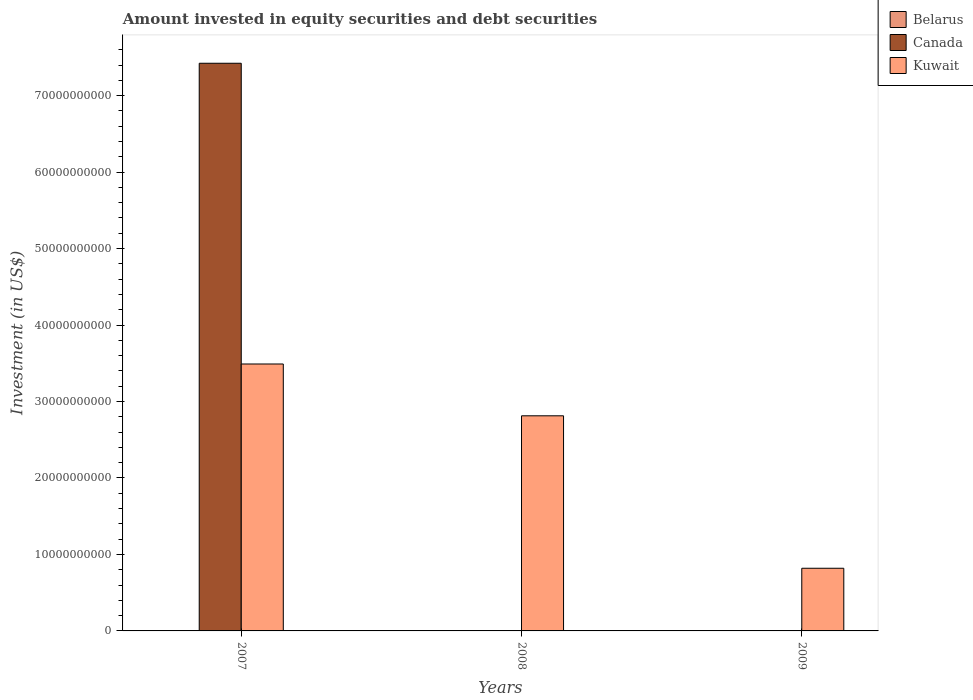How many different coloured bars are there?
Your answer should be compact. 3. Are the number of bars per tick equal to the number of legend labels?
Your answer should be very brief. No. Are the number of bars on each tick of the X-axis equal?
Make the answer very short. No. What is the label of the 3rd group of bars from the left?
Make the answer very short. 2009. In how many cases, is the number of bars for a given year not equal to the number of legend labels?
Make the answer very short. 2. What is the amount invested in equity securities and debt securities in Belarus in 2007?
Give a very brief answer. 3.88e+07. Across all years, what is the maximum amount invested in equity securities and debt securities in Kuwait?
Offer a very short reply. 3.49e+1. Across all years, what is the minimum amount invested in equity securities and debt securities in Canada?
Make the answer very short. 0. In which year was the amount invested in equity securities and debt securities in Belarus maximum?
Provide a succinct answer. 2007. What is the total amount invested in equity securities and debt securities in Kuwait in the graph?
Your answer should be compact. 7.12e+1. What is the difference between the amount invested in equity securities and debt securities in Kuwait in 2007 and that in 2009?
Your response must be concise. 2.67e+1. What is the difference between the amount invested in equity securities and debt securities in Kuwait in 2007 and the amount invested in equity securities and debt securities in Belarus in 2009?
Your answer should be very brief. 3.49e+1. What is the average amount invested in equity securities and debt securities in Kuwait per year?
Your answer should be compact. 2.37e+1. In the year 2007, what is the difference between the amount invested in equity securities and debt securities in Canada and amount invested in equity securities and debt securities in Belarus?
Your response must be concise. 7.42e+1. In how many years, is the amount invested in equity securities and debt securities in Belarus greater than 28000000000 US$?
Make the answer very short. 0. What is the ratio of the amount invested in equity securities and debt securities in Kuwait in 2007 to that in 2009?
Your answer should be very brief. 4.26. What is the difference between the highest and the second highest amount invested in equity securities and debt securities in Kuwait?
Provide a succinct answer. 6.77e+09. What is the difference between the highest and the lowest amount invested in equity securities and debt securities in Belarus?
Offer a very short reply. 3.88e+07. In how many years, is the amount invested in equity securities and debt securities in Kuwait greater than the average amount invested in equity securities and debt securities in Kuwait taken over all years?
Give a very brief answer. 2. Is it the case that in every year, the sum of the amount invested in equity securities and debt securities in Canada and amount invested in equity securities and debt securities in Kuwait is greater than the amount invested in equity securities and debt securities in Belarus?
Provide a short and direct response. Yes. How many bars are there?
Offer a very short reply. 5. Are all the bars in the graph horizontal?
Give a very brief answer. No. How many years are there in the graph?
Make the answer very short. 3. What is the difference between two consecutive major ticks on the Y-axis?
Provide a short and direct response. 1.00e+1. Are the values on the major ticks of Y-axis written in scientific E-notation?
Ensure brevity in your answer.  No. Does the graph contain grids?
Your response must be concise. No. How many legend labels are there?
Keep it short and to the point. 3. How are the legend labels stacked?
Provide a short and direct response. Vertical. What is the title of the graph?
Provide a short and direct response. Amount invested in equity securities and debt securities. What is the label or title of the Y-axis?
Provide a succinct answer. Investment (in US$). What is the Investment (in US$) in Belarus in 2007?
Your answer should be compact. 3.88e+07. What is the Investment (in US$) in Canada in 2007?
Give a very brief answer. 7.42e+1. What is the Investment (in US$) of Kuwait in 2007?
Your response must be concise. 3.49e+1. What is the Investment (in US$) in Belarus in 2008?
Give a very brief answer. 0. What is the Investment (in US$) of Kuwait in 2008?
Offer a very short reply. 2.81e+1. What is the Investment (in US$) of Belarus in 2009?
Your response must be concise. 0. What is the Investment (in US$) in Kuwait in 2009?
Your response must be concise. 8.19e+09. Across all years, what is the maximum Investment (in US$) in Belarus?
Your answer should be compact. 3.88e+07. Across all years, what is the maximum Investment (in US$) in Canada?
Ensure brevity in your answer.  7.42e+1. Across all years, what is the maximum Investment (in US$) of Kuwait?
Make the answer very short. 3.49e+1. Across all years, what is the minimum Investment (in US$) of Belarus?
Keep it short and to the point. 0. Across all years, what is the minimum Investment (in US$) in Canada?
Offer a terse response. 0. Across all years, what is the minimum Investment (in US$) of Kuwait?
Give a very brief answer. 8.19e+09. What is the total Investment (in US$) in Belarus in the graph?
Provide a short and direct response. 3.88e+07. What is the total Investment (in US$) of Canada in the graph?
Your response must be concise. 7.42e+1. What is the total Investment (in US$) in Kuwait in the graph?
Your answer should be very brief. 7.12e+1. What is the difference between the Investment (in US$) of Kuwait in 2007 and that in 2008?
Your response must be concise. 6.77e+09. What is the difference between the Investment (in US$) in Kuwait in 2007 and that in 2009?
Provide a succinct answer. 2.67e+1. What is the difference between the Investment (in US$) of Kuwait in 2008 and that in 2009?
Offer a very short reply. 1.99e+1. What is the difference between the Investment (in US$) of Belarus in 2007 and the Investment (in US$) of Kuwait in 2008?
Give a very brief answer. -2.81e+1. What is the difference between the Investment (in US$) of Canada in 2007 and the Investment (in US$) of Kuwait in 2008?
Offer a very short reply. 4.61e+1. What is the difference between the Investment (in US$) in Belarus in 2007 and the Investment (in US$) in Kuwait in 2009?
Your answer should be compact. -8.16e+09. What is the difference between the Investment (in US$) of Canada in 2007 and the Investment (in US$) of Kuwait in 2009?
Provide a succinct answer. 6.60e+1. What is the average Investment (in US$) in Belarus per year?
Your response must be concise. 1.29e+07. What is the average Investment (in US$) in Canada per year?
Your answer should be very brief. 2.47e+1. What is the average Investment (in US$) of Kuwait per year?
Ensure brevity in your answer.  2.37e+1. In the year 2007, what is the difference between the Investment (in US$) in Belarus and Investment (in US$) in Canada?
Your response must be concise. -7.42e+1. In the year 2007, what is the difference between the Investment (in US$) in Belarus and Investment (in US$) in Kuwait?
Provide a succinct answer. -3.49e+1. In the year 2007, what is the difference between the Investment (in US$) of Canada and Investment (in US$) of Kuwait?
Offer a terse response. 3.93e+1. What is the ratio of the Investment (in US$) in Kuwait in 2007 to that in 2008?
Give a very brief answer. 1.24. What is the ratio of the Investment (in US$) of Kuwait in 2007 to that in 2009?
Your answer should be very brief. 4.26. What is the ratio of the Investment (in US$) of Kuwait in 2008 to that in 2009?
Offer a terse response. 3.43. What is the difference between the highest and the second highest Investment (in US$) of Kuwait?
Keep it short and to the point. 6.77e+09. What is the difference between the highest and the lowest Investment (in US$) in Belarus?
Offer a very short reply. 3.88e+07. What is the difference between the highest and the lowest Investment (in US$) in Canada?
Provide a short and direct response. 7.42e+1. What is the difference between the highest and the lowest Investment (in US$) of Kuwait?
Make the answer very short. 2.67e+1. 